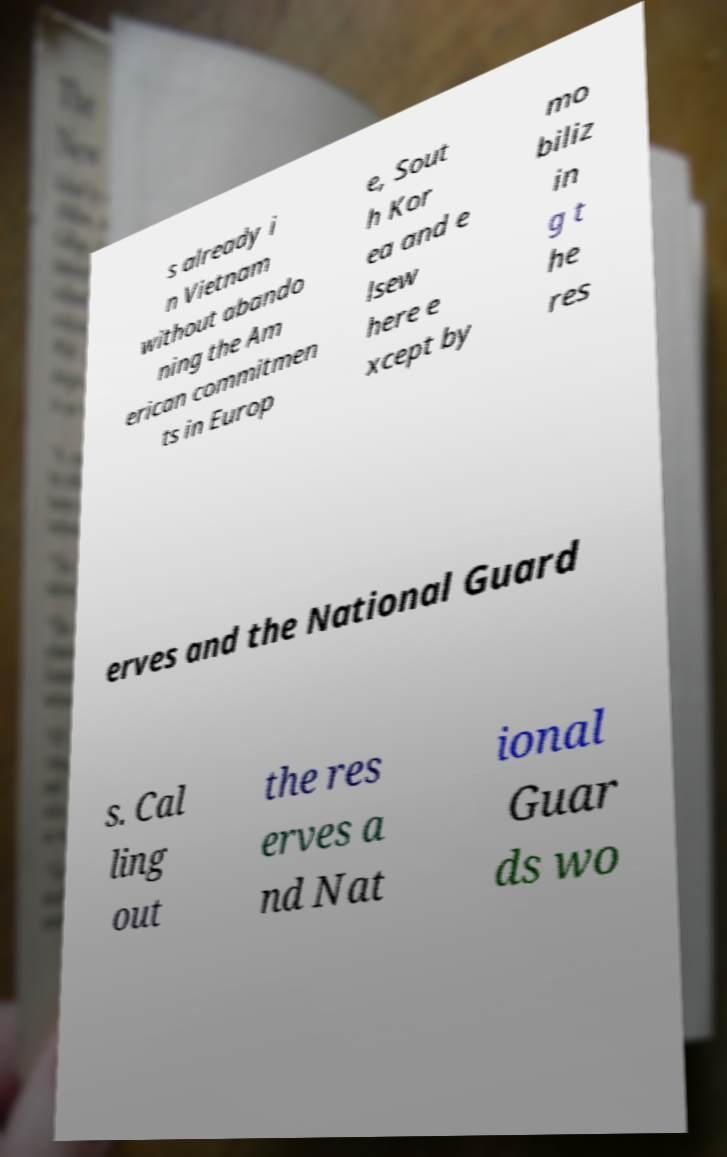Please identify and transcribe the text found in this image. s already i n Vietnam without abando ning the Am erican commitmen ts in Europ e, Sout h Kor ea and e lsew here e xcept by mo biliz in g t he res erves and the National Guard s. Cal ling out the res erves a nd Nat ional Guar ds wo 